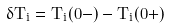Convert formula to latex. <formula><loc_0><loc_0><loc_500><loc_500>\delta T _ { i } = T _ { i } ( 0 - ) - T _ { i } ( 0 + )</formula> 